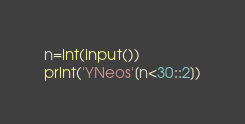Convert code to text. <code><loc_0><loc_0><loc_500><loc_500><_Python_>n=int(input())
print('YNeos'[n<30::2])</code> 